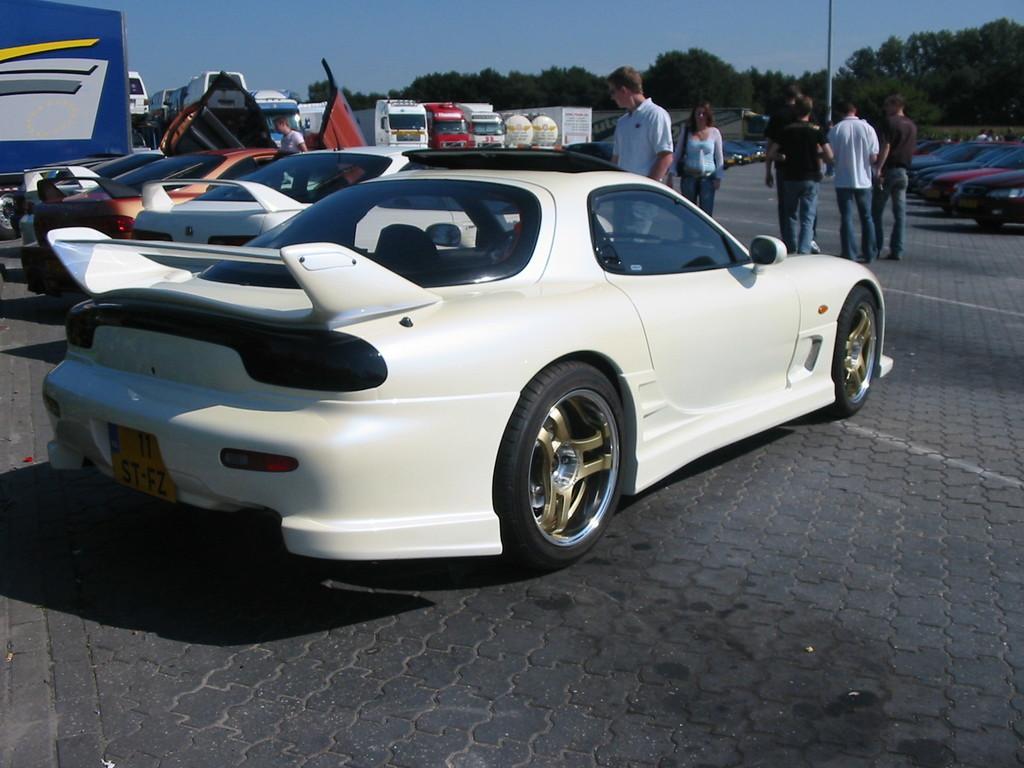Could you give a brief overview of what you see in this image? In the image in the center, we can see few vehicles. And we can see a few people are standing. In the background, we can see the sky, trees, one pole and a few other objects. 